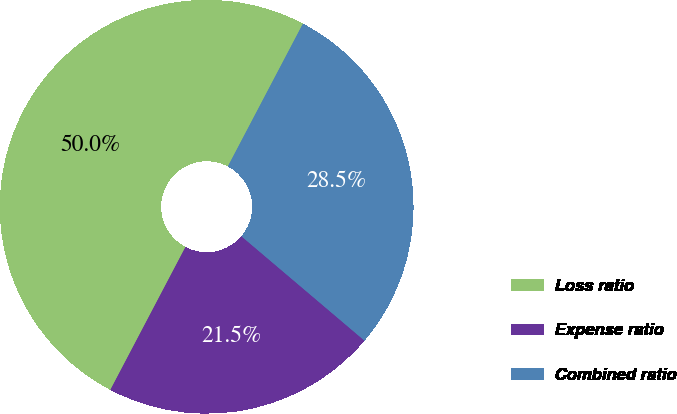Convert chart. <chart><loc_0><loc_0><loc_500><loc_500><pie_chart><fcel>Loss ratio<fcel>Expense ratio<fcel>Combined ratio<nl><fcel>50.0%<fcel>21.51%<fcel>28.49%<nl></chart> 